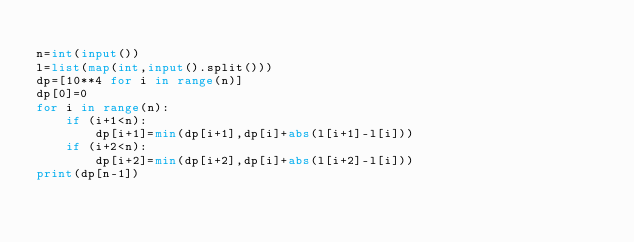<code> <loc_0><loc_0><loc_500><loc_500><_Python_>
n=int(input())
l=list(map(int,input().split()))
dp=[10**4 for i in range(n)]
dp[0]=0
for i in range(n):
    if (i+1<n):
        dp[i+1]=min(dp[i+1],dp[i]+abs(l[i+1]-l[i]))
    if (i+2<n):
        dp[i+2]=min(dp[i+2],dp[i]+abs(l[i+2]-l[i]))
print(dp[n-1]) </code> 